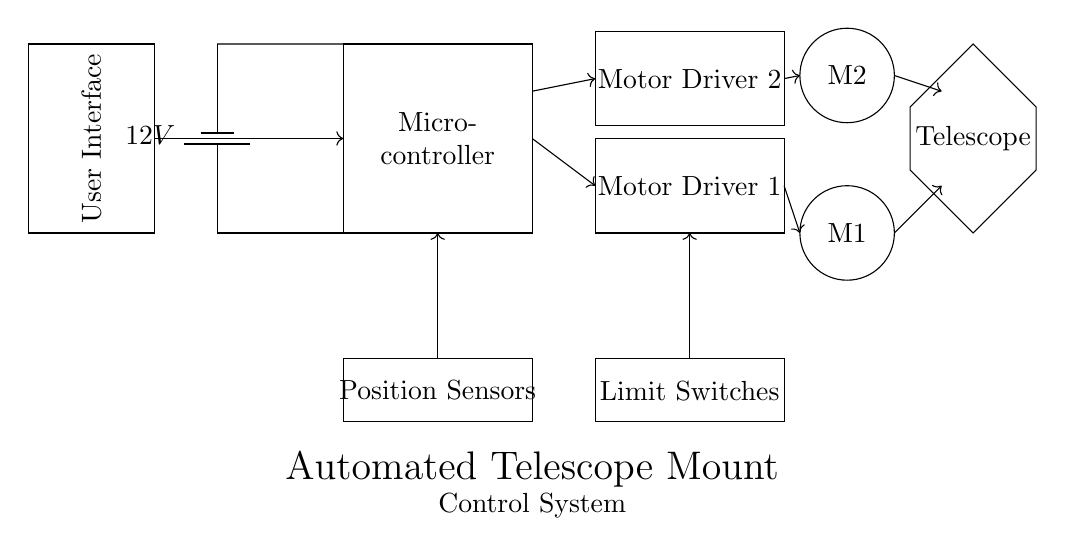What type of power supply is used? The circuit uses a battery as the power supply, indicated by the battery symbol in the diagram.
Answer: Battery How many motor drivers are present? There are two motor drivers shown in the circuit, each represented by a separate rectangle labeled "Motor Driver 1" and "Motor Driver 2".
Answer: Two What is the connection from the microcontroller to motor driver one? The microcontroller connects to motor driver one through a single directed arrow indicating a control signal, which signifies communication between the two components.
Answer: Control signal What components are used for position sensing? The components used for position sensing are labeled as "Position Sensors" in a rectangular box located below the microcontroller.
Answer: Position Sensors How does the user interface connect to the system? The user interface connects to the microcontroller with a directed arrow, indicating that it sends commands or receives information from the microcontroller, essential for user input to control the telescope.
Answer: Through a directed arrow What additional safety feature is included in the design? The design includes "Limit Switches", which are critical components to prevent the motors from moving beyond their designated limits, thus ensuring safety.
Answer: Limit Switches What do the circles labeled M1 and M2 represent? The circles labeled M1 and M2 represent the motors in the telescope mount system, indicating the two distinct motors used for movement in the system.
Answer: Motors 